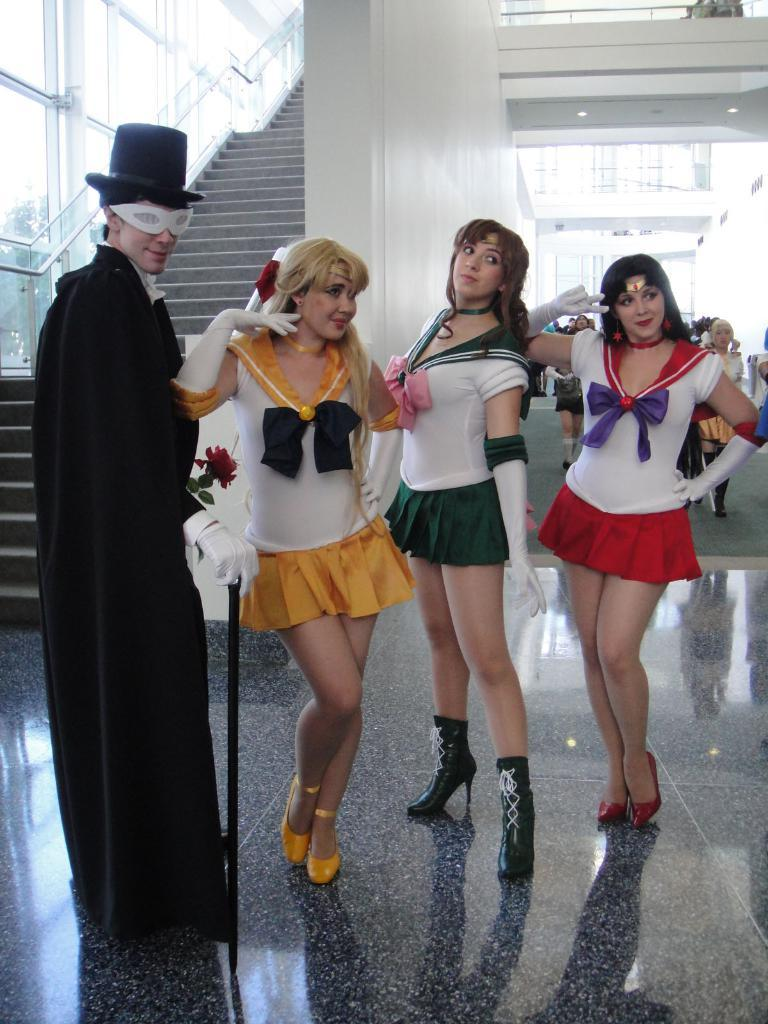What are the persons in the image wearing? The persons in the image are wearing costumes. What can be seen in the background of the image? There is a glass wall in the background of the image. Are there any architectural features in the image? Yes, there are steps and another wall in the image. How many people are present in the image? There are people in the image, but the exact number is not specified. What type of print can be seen on the costumes in the image? There is no information about the print on the costumes in the image. What time of day is it in the image? The time of day is not specified in the image. 